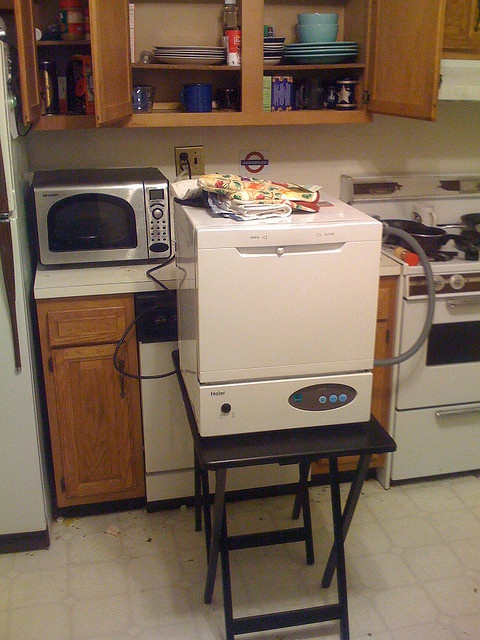Describe the objects in this image and their specific colors. I can see oven in maroon, darkgray, gray, and black tones, refrigerator in maroon, darkgray, gray, and black tones, microwave in maroon, black, gray, and darkgray tones, cup in maroon, navy, black, and purple tones, and bowl in maroon, teal, and gray tones in this image. 